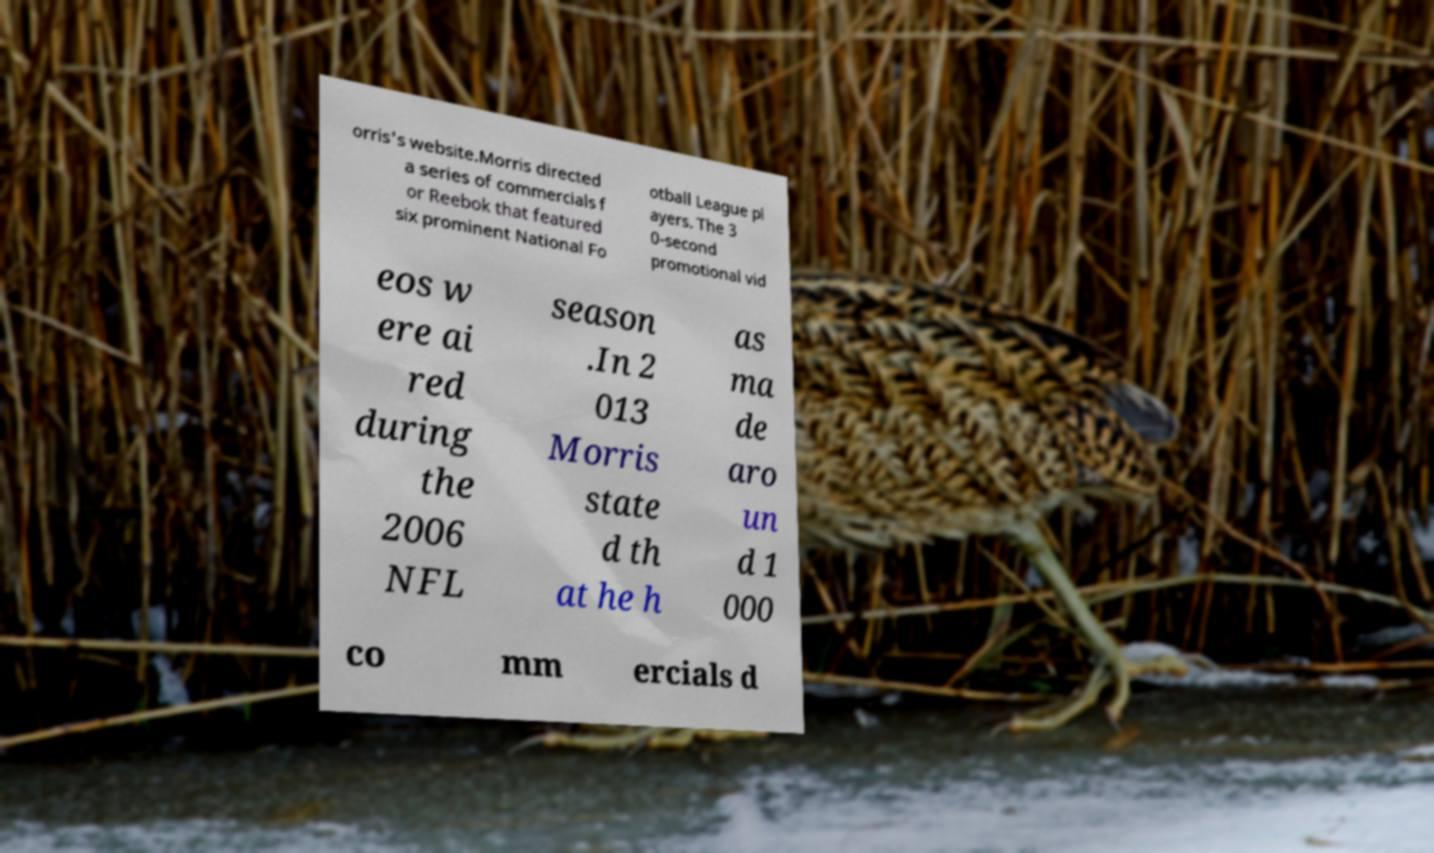Could you assist in decoding the text presented in this image and type it out clearly? orris's website.Morris directed a series of commercials f or Reebok that featured six prominent National Fo otball League pl ayers. The 3 0-second promotional vid eos w ere ai red during the 2006 NFL season .In 2 013 Morris state d th at he h as ma de aro un d 1 000 co mm ercials d 